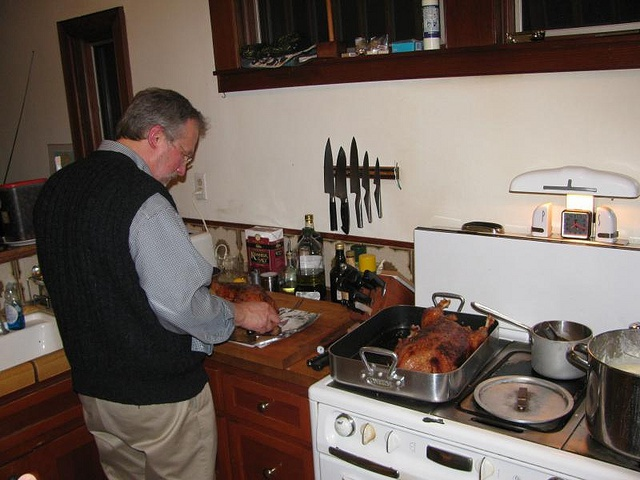Describe the objects in this image and their specific colors. I can see people in black and gray tones, oven in black, lightgray, darkgray, and gray tones, sink in black, darkgray, and gray tones, bottle in black, darkgray, and gray tones, and clock in black, gray, and white tones in this image. 